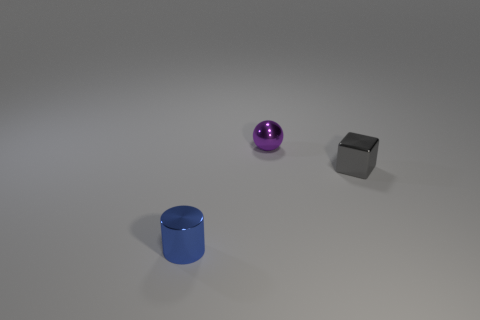Subtract all blocks. How many objects are left? 2 Subtract 1 balls. How many balls are left? 0 Add 1 tiny blue shiny cylinders. How many tiny blue shiny cylinders are left? 2 Add 2 tiny blue cylinders. How many tiny blue cylinders exist? 3 Add 3 blue shiny cylinders. How many objects exist? 6 Subtract 1 gray cubes. How many objects are left? 2 Subtract all green cylinders. Subtract all cyan blocks. How many cylinders are left? 1 Subtract all brown cylinders. How many yellow blocks are left? 0 Subtract all purple metal balls. Subtract all big purple rubber cylinders. How many objects are left? 2 